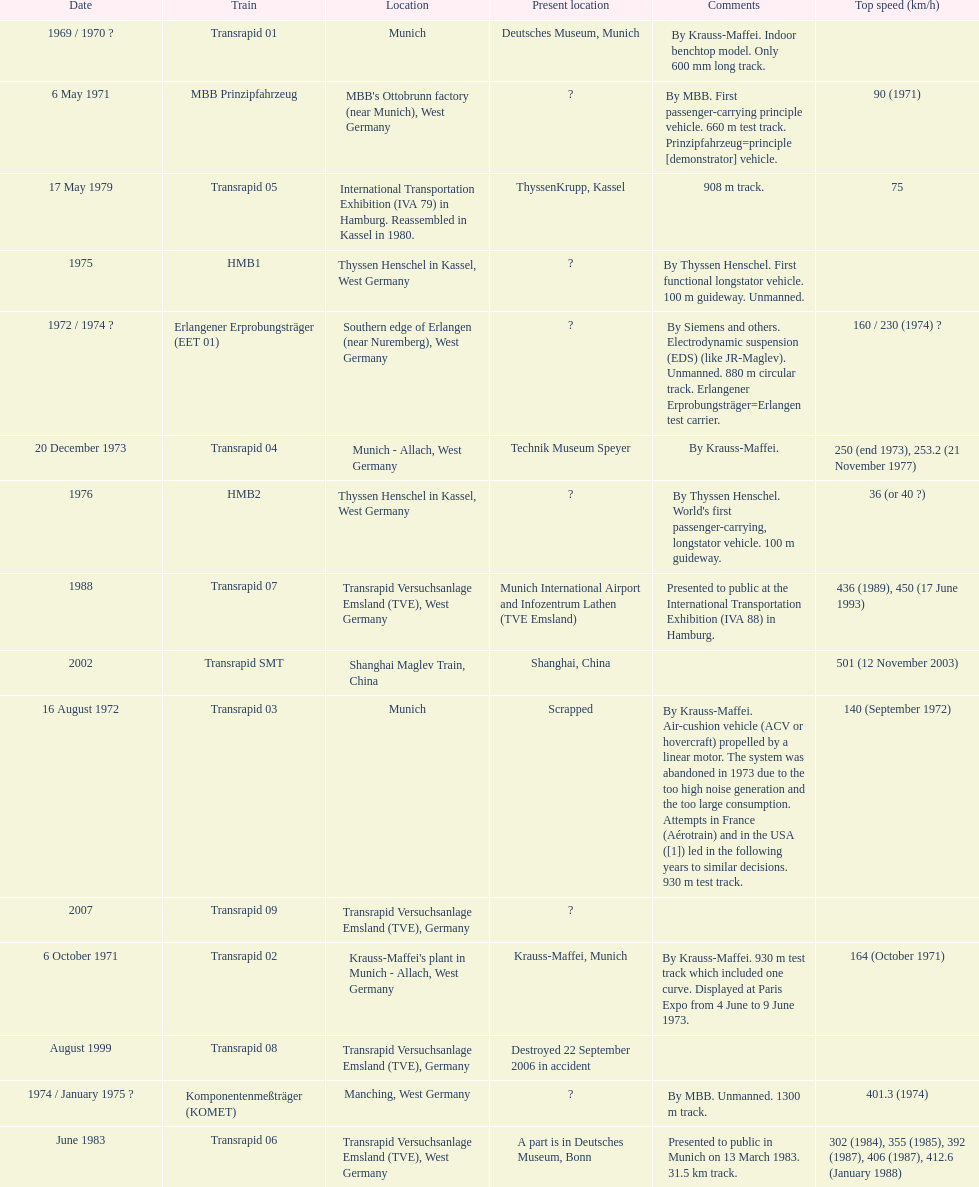Tell me the number of versions that are scrapped. 1. 